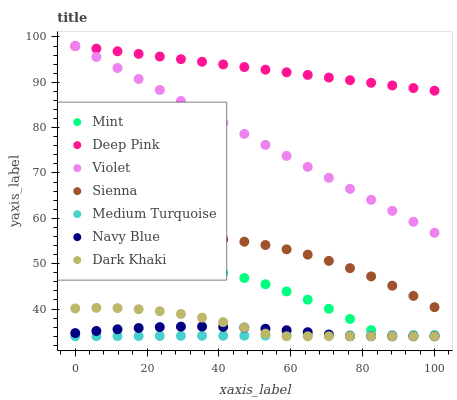Does Medium Turquoise have the minimum area under the curve?
Answer yes or no. Yes. Does Deep Pink have the maximum area under the curve?
Answer yes or no. Yes. Does Navy Blue have the minimum area under the curve?
Answer yes or no. No. Does Navy Blue have the maximum area under the curve?
Answer yes or no. No. Is Medium Turquoise the smoothest?
Answer yes or no. Yes. Is Mint the roughest?
Answer yes or no. Yes. Is Deep Pink the smoothest?
Answer yes or no. No. Is Deep Pink the roughest?
Answer yes or no. No. Does Dark Khaki have the lowest value?
Answer yes or no. Yes. Does Deep Pink have the lowest value?
Answer yes or no. No. Does Violet have the highest value?
Answer yes or no. Yes. Does Navy Blue have the highest value?
Answer yes or no. No. Is Navy Blue less than Violet?
Answer yes or no. Yes. Is Sienna greater than Dark Khaki?
Answer yes or no. Yes. Does Dark Khaki intersect Navy Blue?
Answer yes or no. Yes. Is Dark Khaki less than Navy Blue?
Answer yes or no. No. Is Dark Khaki greater than Navy Blue?
Answer yes or no. No. Does Navy Blue intersect Violet?
Answer yes or no. No. 